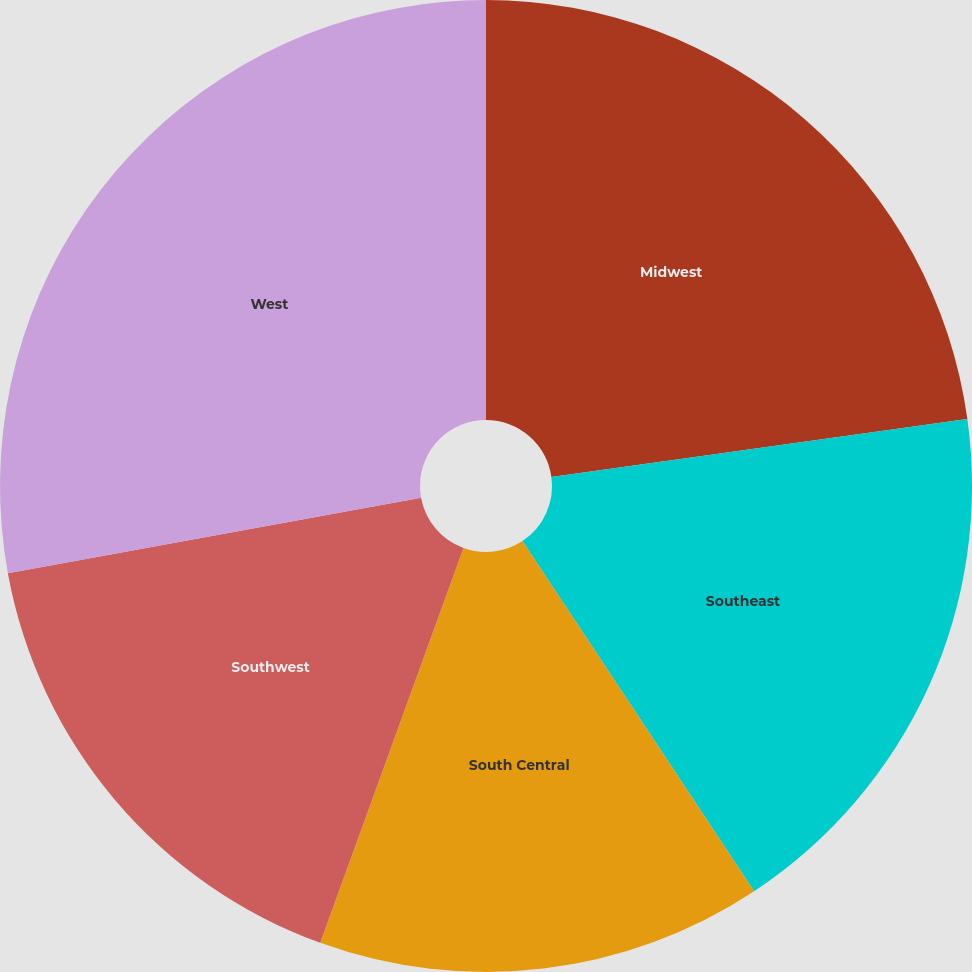Convert chart to OTSL. <chart><loc_0><loc_0><loc_500><loc_500><pie_chart><fcel>Midwest<fcel>Southeast<fcel>South Central<fcel>Southwest<fcel>West<nl><fcel>22.8%<fcel>17.9%<fcel>14.84%<fcel>16.59%<fcel>27.87%<nl></chart> 